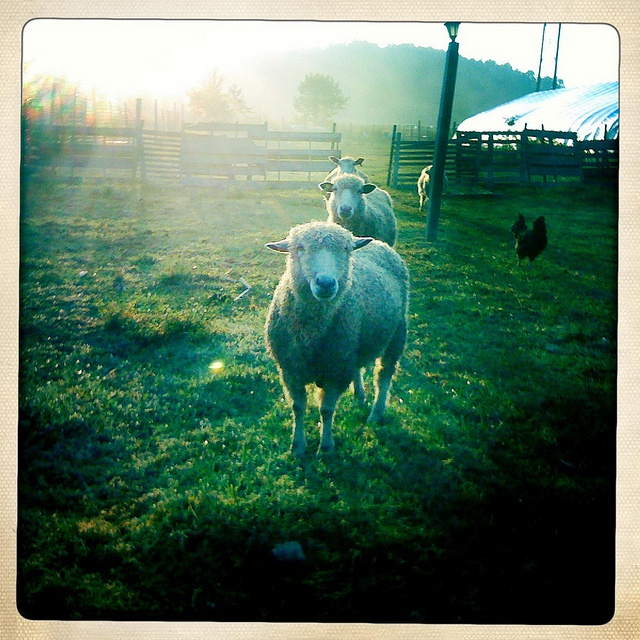Describe the objects in this image and their specific colors. I can see sheep in beige, teal, black, and darkgreen tones, sheep in beige, teal, darkgray, and turquoise tones, bird in beige, black, darkgreen, and green tones, bird in beige, black, darkgreen, and green tones, and sheep in beige, turquoise, darkgray, and aquamarine tones in this image. 